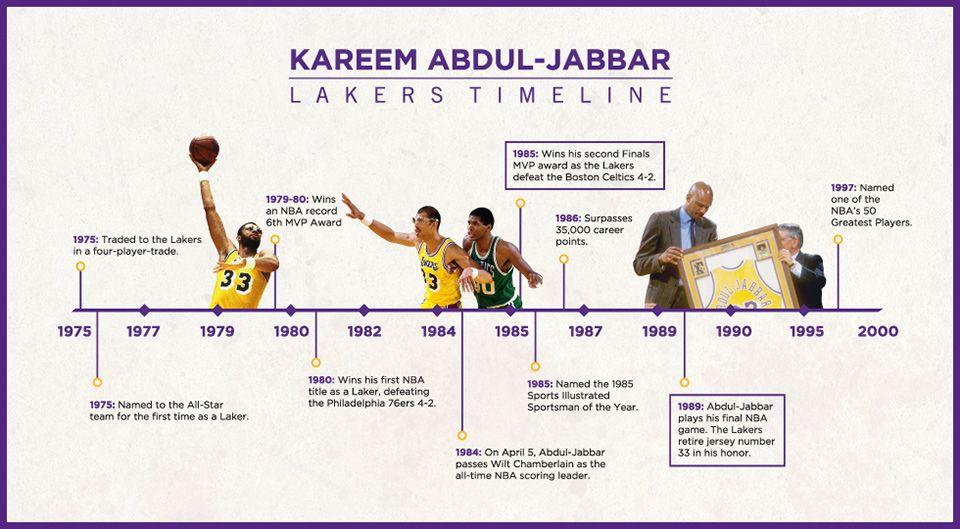Give some essential details in this illustration. Kareem Abdul-Jabbar joined the Los Angeles Lakers in 1975. On February 24, 1989, the Los Angeles Lakers retired the jersey number 33 in honor of their former player. Kareem Abdul-Jabbar wore jersey number 33 during his playing career. During the period of 1985 to 2000, a total of 5 achievements have been highlighted. 